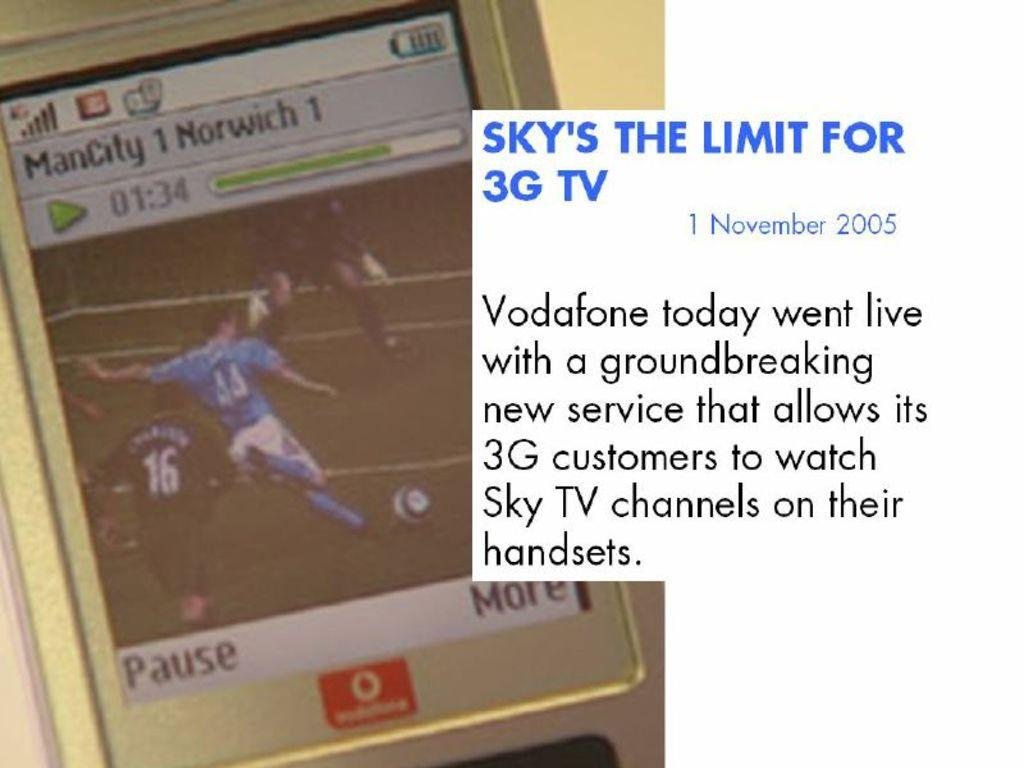Provide a one-sentence caption for the provided image. An advertisement for Vodaphone's new 3G television technology. 